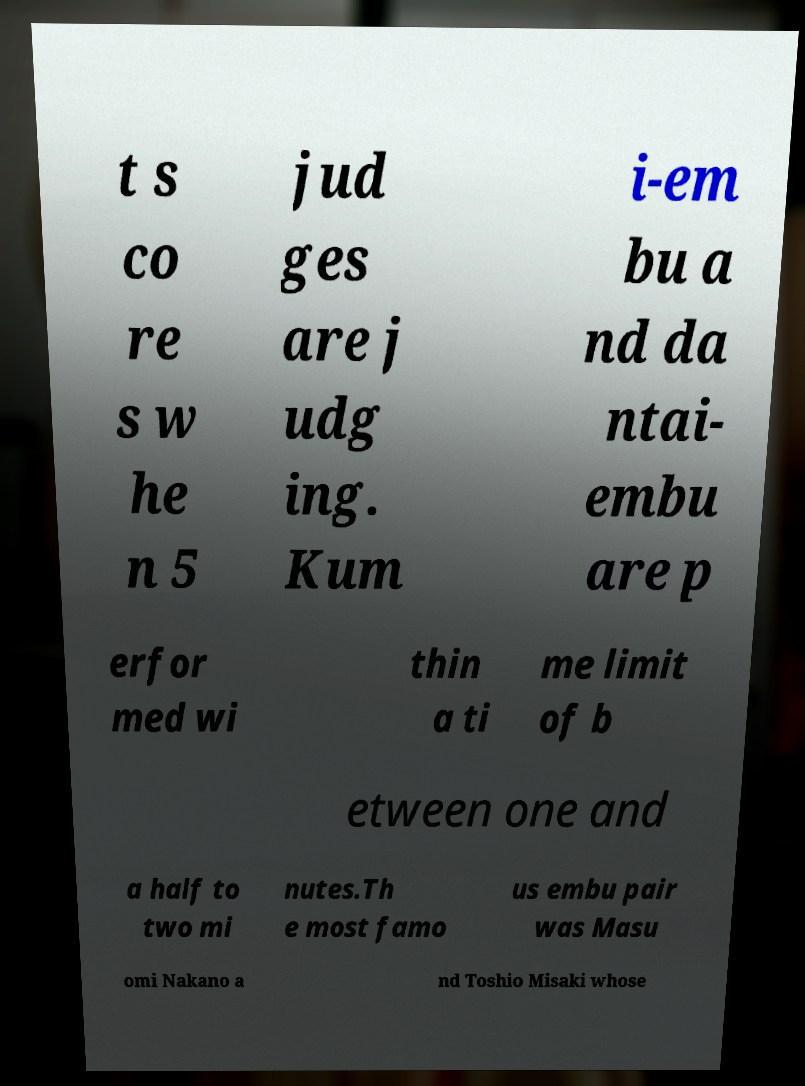Could you extract and type out the text from this image? t s co re s w he n 5 jud ges are j udg ing. Kum i-em bu a nd da ntai- embu are p erfor med wi thin a ti me limit of b etween one and a half to two mi nutes.Th e most famo us embu pair was Masu omi Nakano a nd Toshio Misaki whose 